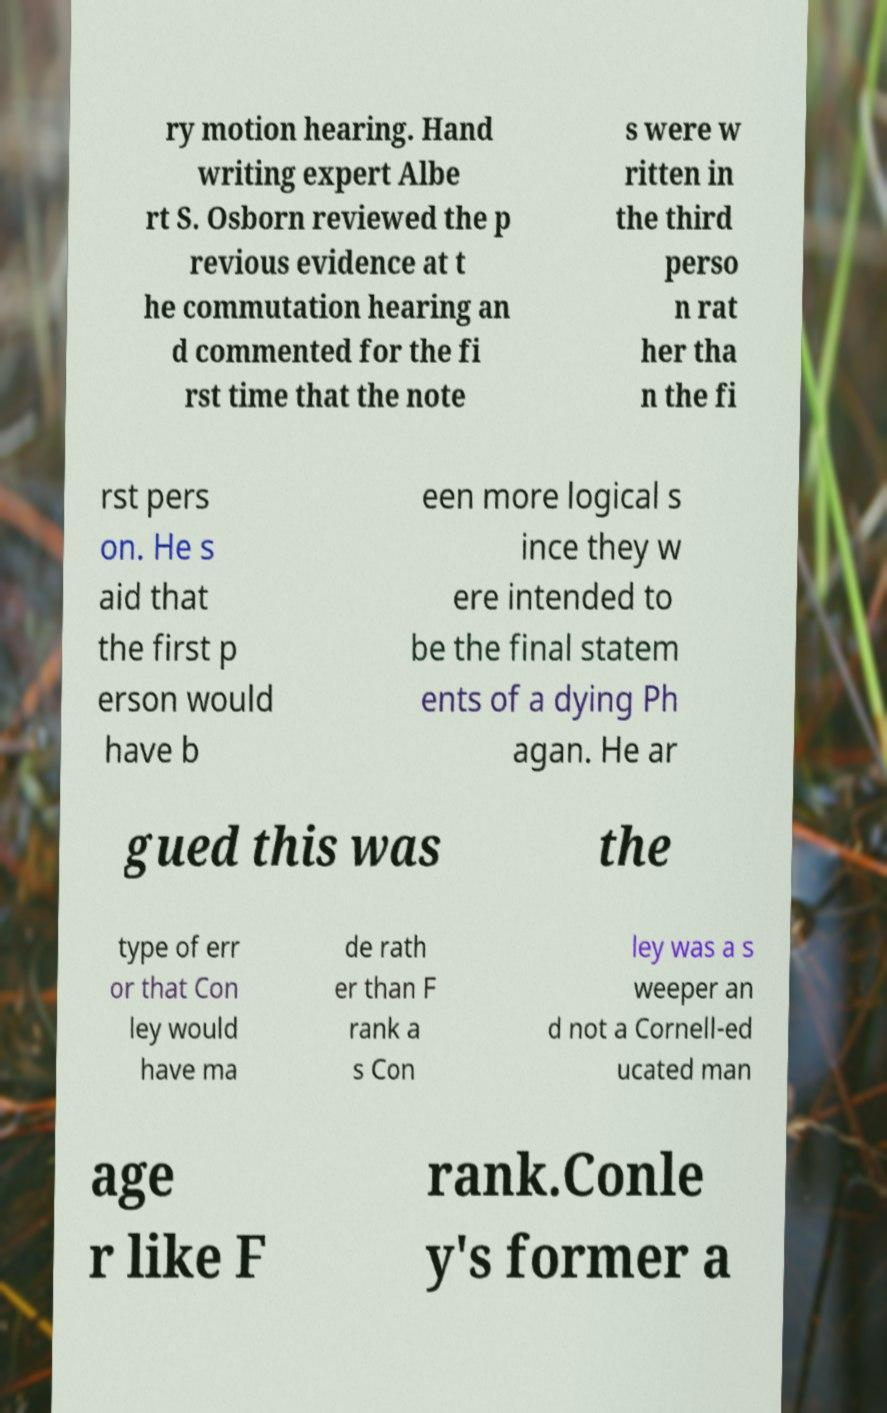There's text embedded in this image that I need extracted. Can you transcribe it verbatim? ry motion hearing. Hand writing expert Albe rt S. Osborn reviewed the p revious evidence at t he commutation hearing an d commented for the fi rst time that the note s were w ritten in the third perso n rat her tha n the fi rst pers on. He s aid that the first p erson would have b een more logical s ince they w ere intended to be the final statem ents of a dying Ph agan. He ar gued this was the type of err or that Con ley would have ma de rath er than F rank a s Con ley was a s weeper an d not a Cornell-ed ucated man age r like F rank.Conle y's former a 